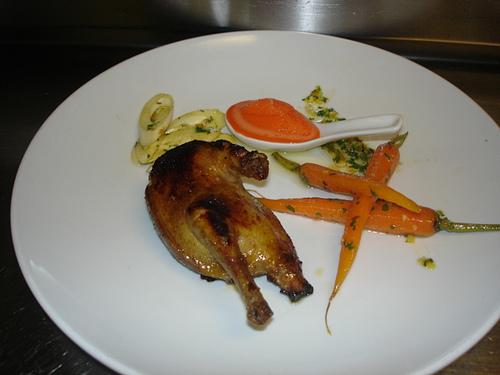Is this a small meal?
Answer briefly. Yes. What meal is this?
Keep it brief. Dinner. What kind of meat is on the plate?
Concise answer only. Chicken. Which vegetable is shown?
Write a very short answer. Carrot. What vegetable are on the plate?
Answer briefly. Carrots. Is this a good lunch for someone on a low carb diet?
Concise answer only. Yes. What type of meat is pictured?
Give a very brief answer. Chicken. Are the carrots cooked?
Answer briefly. Yes. Are there green vegetables on the plate?
Keep it brief. No. Are there any designs on the plate itself?
Give a very brief answer. No. Does this meal contain any dairy products?
Answer briefly. No. Is this breakfast?
Give a very brief answer. No. How many bowls?
Answer briefly. 0. Could a lactose-intolerant person enjoy this meal?
Give a very brief answer. Yes. How many sets of three carrots are on the plate?
Be succinct. 1. Is this homemade or from a restaurant?
Quick response, please. Restaurant. Are green beans on the plate?
Quick response, please. No. What type of vegetables are on the plate?
Answer briefly. Carrots. What color is the plate?
Write a very short answer. White. 